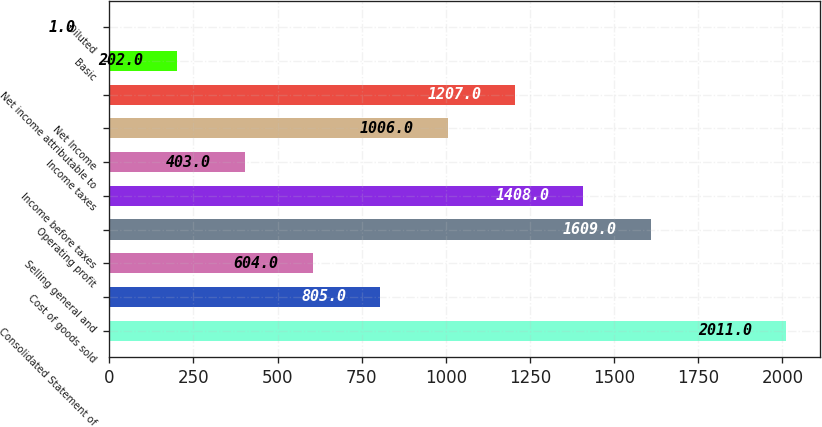Convert chart to OTSL. <chart><loc_0><loc_0><loc_500><loc_500><bar_chart><fcel>Consolidated Statement of<fcel>Cost of goods sold<fcel>Selling general and<fcel>Operating profit<fcel>Income before taxes<fcel>Income taxes<fcel>Net Income<fcel>Net income attributable to<fcel>Basic<fcel>Diluted<nl><fcel>2011<fcel>805<fcel>604<fcel>1609<fcel>1408<fcel>403<fcel>1006<fcel>1207<fcel>202<fcel>1<nl></chart> 